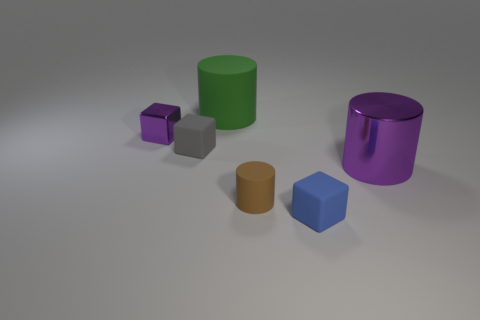What number of red matte things are the same shape as the large purple metal thing?
Keep it short and to the point. 0. Is there a cylinder of the same color as the tiny metallic block?
Offer a terse response. Yes. What number of things are purple metallic objects in front of the small purple metal cube or purple objects on the right side of the brown rubber cylinder?
Offer a very short reply. 1. There is a big thing that is in front of the small purple metal cube; is there a small matte cylinder that is in front of it?
Offer a very short reply. Yes. What shape is the blue rubber thing that is the same size as the purple cube?
Ensure brevity in your answer.  Cube. What number of objects are either rubber objects that are to the right of the small brown matte object or purple objects?
Offer a terse response. 3. How many other objects are the same material as the purple cube?
Your answer should be compact. 1. What shape is the big thing that is the same color as the small metallic object?
Ensure brevity in your answer.  Cylinder. There is a purple shiny object to the right of the small brown thing; what size is it?
Keep it short and to the point. Large. What is the shape of the tiny blue thing that is made of the same material as the brown cylinder?
Your answer should be very brief. Cube. 